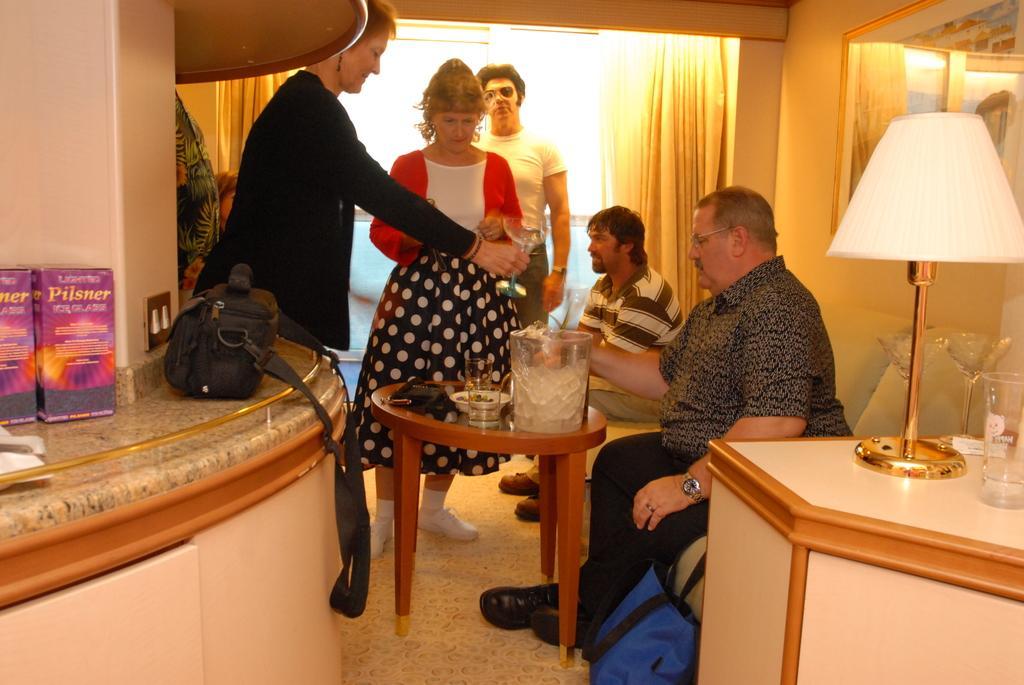How would you summarize this image in a sentence or two? In the image in the center, we can see two persons are sitting and few people are standing. Between them, we can see one table. On the table, there is a bowl, glass and container. And on the left and right side, we can see tables. On the tables, we can see one glass, packets etc.. In the background there is a wall, mirror and curtain. 